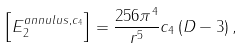Convert formula to latex. <formula><loc_0><loc_0><loc_500><loc_500>\left [ E _ { 2 } ^ { a n n u l u s , c _ { 4 } } \right ] = \frac { 2 5 6 \pi ^ { 4 } } { r ^ { 5 } } c _ { 4 } \left ( D - 3 \right ) ,</formula> 